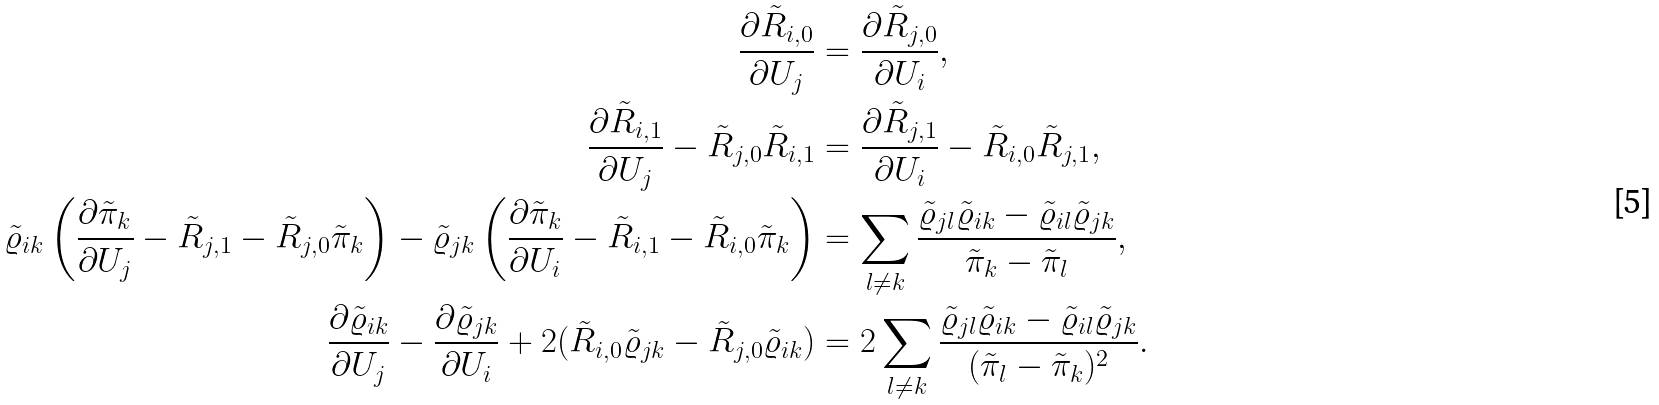Convert formula to latex. <formula><loc_0><loc_0><loc_500><loc_500>\frac { \partial \tilde { R } _ { i , 0 } } { \partial U _ { j } } & = \frac { \partial \tilde { R } _ { j , 0 } } { \partial U _ { i } } , \\ \frac { \partial \tilde { R } _ { i , 1 } } { \partial U _ { j } } - \tilde { R } _ { j , 0 } \tilde { R } _ { i , 1 } & = \frac { \partial \tilde { R } _ { j , 1 } } { \partial U _ { i } } - \tilde { R } _ { i , 0 } \tilde { R } _ { j , 1 } , \\ \tilde { \varrho } _ { i k } \left ( \frac { \partial \tilde { \pi } _ { k } } { \partial U _ { j } } - \tilde { R } _ { j , 1 } - \tilde { R } _ { j , 0 } \tilde { \pi } _ { k } \right ) - \tilde { \varrho } _ { j k } \left ( \frac { \partial \tilde { \pi } _ { k } } { \partial U _ { i } } - \tilde { R } _ { i , 1 } - \tilde { R } _ { i , 0 } \tilde { \pi } _ { k } \right ) & = \sum _ { l \neq k } \frac { \tilde { \varrho } _ { j l } \tilde { \varrho } _ { i k } - \tilde { \varrho } _ { i l } \tilde { \varrho } _ { j k } } { \tilde { \pi } _ { k } - \tilde { \pi } _ { l } } , \\ \frac { \partial \tilde { \varrho } _ { i k } } { \partial U _ { j } } - \frac { \partial \tilde { \varrho } _ { j k } } { \partial U _ { i } } + 2 ( \tilde { R } _ { i , 0 } \tilde { \varrho } _ { j k } - \tilde { R } _ { j , 0 } \tilde { \varrho } _ { i k } ) & = 2 \sum _ { l \neq k } \frac { \tilde { \varrho } _ { j l } \tilde { \varrho } _ { i k } - \tilde { \varrho } _ { i l } \tilde { \varrho } _ { j k } } { ( \tilde { \pi } _ { l } - \tilde { \pi } _ { k } ) ^ { 2 } } .</formula> 